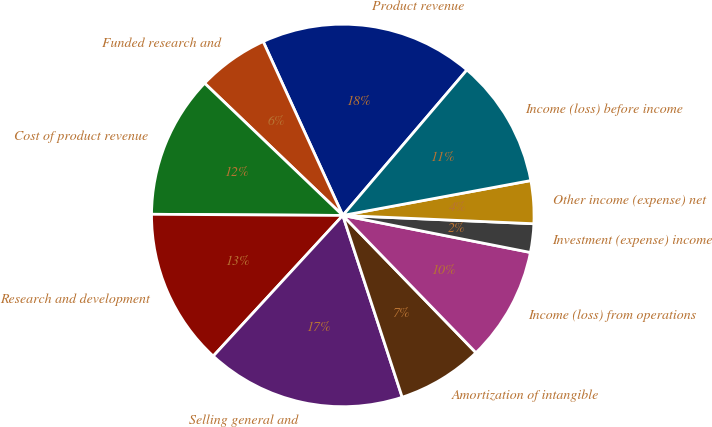Convert chart to OTSL. <chart><loc_0><loc_0><loc_500><loc_500><pie_chart><fcel>Product revenue<fcel>Funded research and<fcel>Cost of product revenue<fcel>Research and development<fcel>Selling general and<fcel>Amortization of intangible<fcel>Income (loss) from operations<fcel>Investment (expense) income<fcel>Other income (expense) net<fcel>Income (loss) before income<nl><fcel>18.07%<fcel>6.02%<fcel>12.05%<fcel>13.25%<fcel>16.87%<fcel>7.23%<fcel>9.64%<fcel>2.41%<fcel>3.61%<fcel>10.84%<nl></chart> 